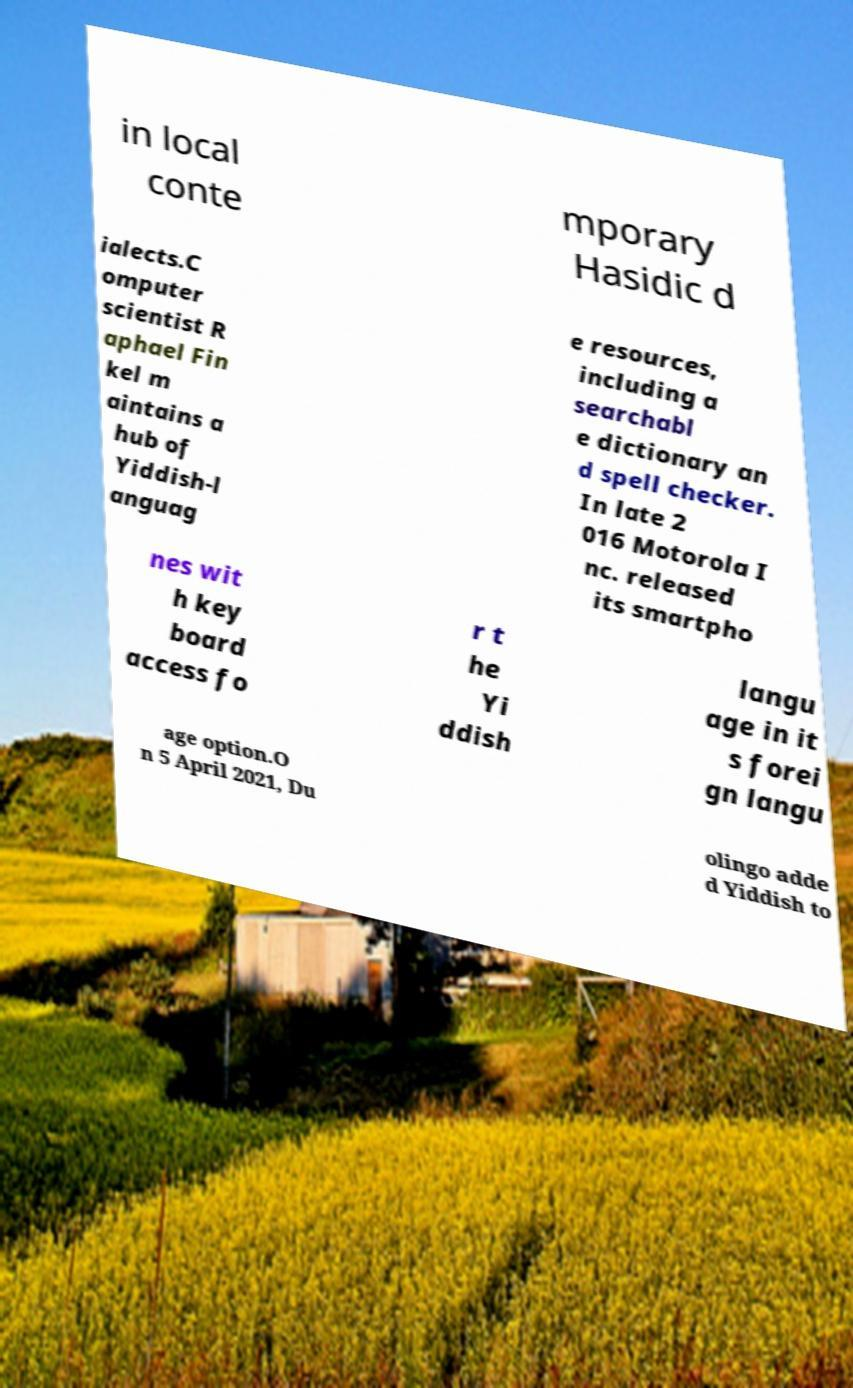Can you read and provide the text displayed in the image?This photo seems to have some interesting text. Can you extract and type it out for me? in local conte mporary Hasidic d ialects.C omputer scientist R aphael Fin kel m aintains a hub of Yiddish-l anguag e resources, including a searchabl e dictionary an d spell checker. In late 2 016 Motorola I nc. released its smartpho nes wit h key board access fo r t he Yi ddish langu age in it s forei gn langu age option.O n 5 April 2021, Du olingo adde d Yiddish to 